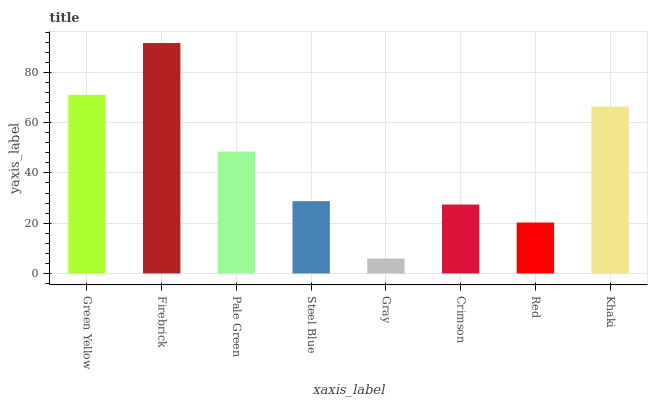Is Gray the minimum?
Answer yes or no. Yes. Is Firebrick the maximum?
Answer yes or no. Yes. Is Pale Green the minimum?
Answer yes or no. No. Is Pale Green the maximum?
Answer yes or no. No. Is Firebrick greater than Pale Green?
Answer yes or no. Yes. Is Pale Green less than Firebrick?
Answer yes or no. Yes. Is Pale Green greater than Firebrick?
Answer yes or no. No. Is Firebrick less than Pale Green?
Answer yes or no. No. Is Pale Green the high median?
Answer yes or no. Yes. Is Steel Blue the low median?
Answer yes or no. Yes. Is Firebrick the high median?
Answer yes or no. No. Is Crimson the low median?
Answer yes or no. No. 